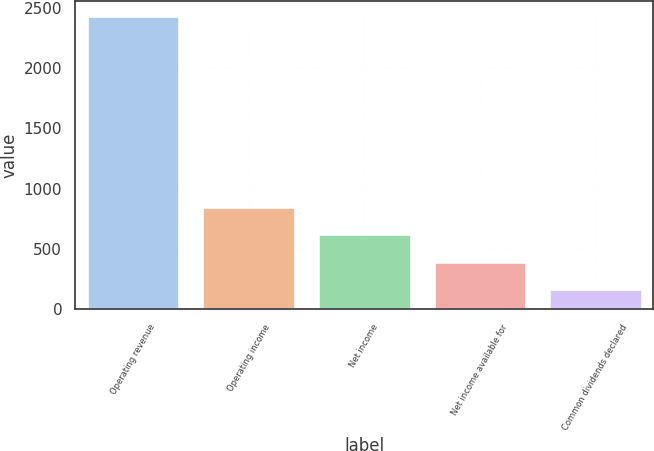Convert chart to OTSL. <chart><loc_0><loc_0><loc_500><loc_500><bar_chart><fcel>Operating revenue<fcel>Operating income<fcel>Net income<fcel>Net income available for<fcel>Common dividends declared<nl><fcel>2435<fcel>849.5<fcel>623<fcel>396.5<fcel>170<nl></chart> 